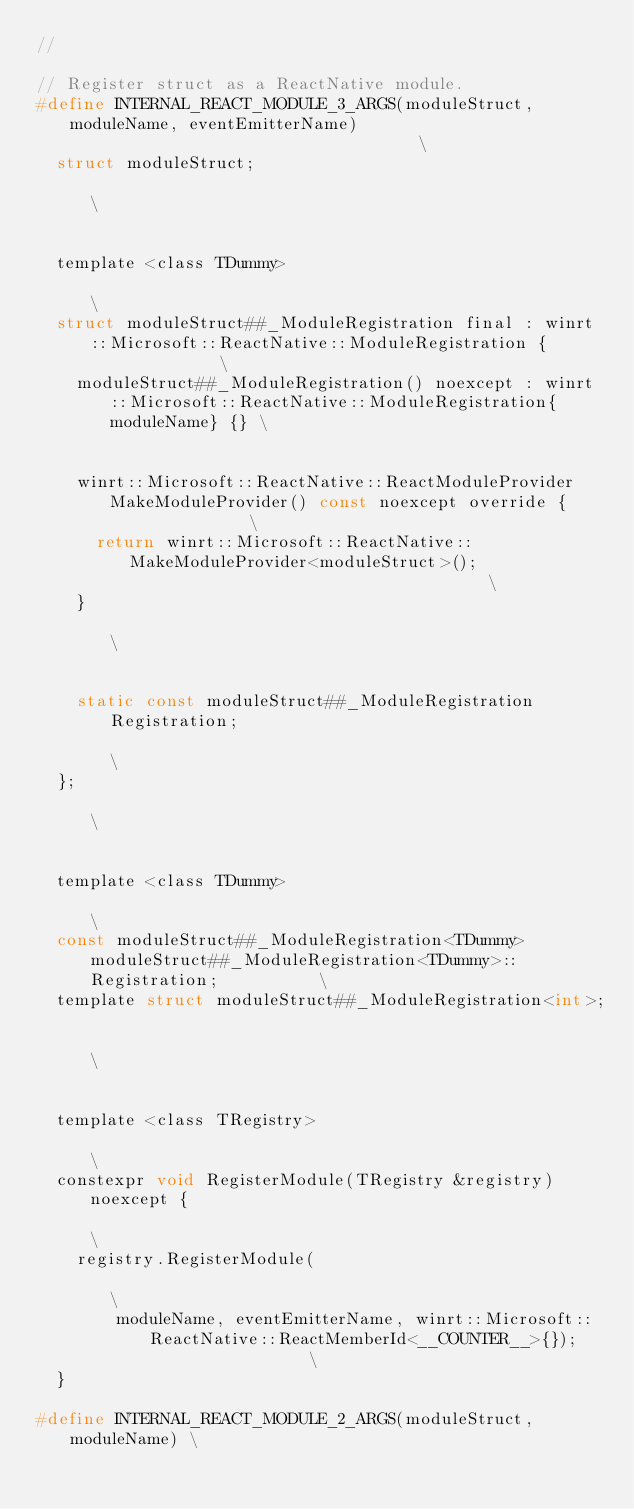Convert code to text. <code><loc_0><loc_0><loc_500><loc_500><_C_>//

// Register struct as a ReactNative module.
#define INTERNAL_REACT_MODULE_3_ARGS(moduleStruct, moduleName, eventEmitterName)                                    \
  struct moduleStruct;                                                                                              \
                                                                                                                    \
  template <class TDummy>                                                                                           \
  struct moduleStruct##_ModuleRegistration final : winrt::Microsoft::ReactNative::ModuleRegistration {              \
    moduleStruct##_ModuleRegistration() noexcept : winrt::Microsoft::ReactNative::ModuleRegistration{moduleName} {} \
                                                                                                                    \
    winrt::Microsoft::ReactNative::ReactModuleProvider MakeModuleProvider() const noexcept override {               \
      return winrt::Microsoft::ReactNative::MakeModuleProvider<moduleStruct>();                                     \
    }                                                                                                               \
                                                                                                                    \
    static const moduleStruct##_ModuleRegistration Registration;                                                    \
  };                                                                                                                \
                                                                                                                    \
  template <class TDummy>                                                                                           \
  const moduleStruct##_ModuleRegistration<TDummy> moduleStruct##_ModuleRegistration<TDummy>::Registration;          \
  template struct moduleStruct##_ModuleRegistration<int>;                                                           \
                                                                                                                    \
  template <class TRegistry>                                                                                        \
  constexpr void RegisterModule(TRegistry &registry) noexcept {                                                     \
    registry.RegisterModule(                                                                                        \
        moduleName, eventEmitterName, winrt::Microsoft::ReactNative::ReactMemberId<__COUNTER__>{});                 \
  }

#define INTERNAL_REACT_MODULE_2_ARGS(moduleStruct, moduleName) \</code> 